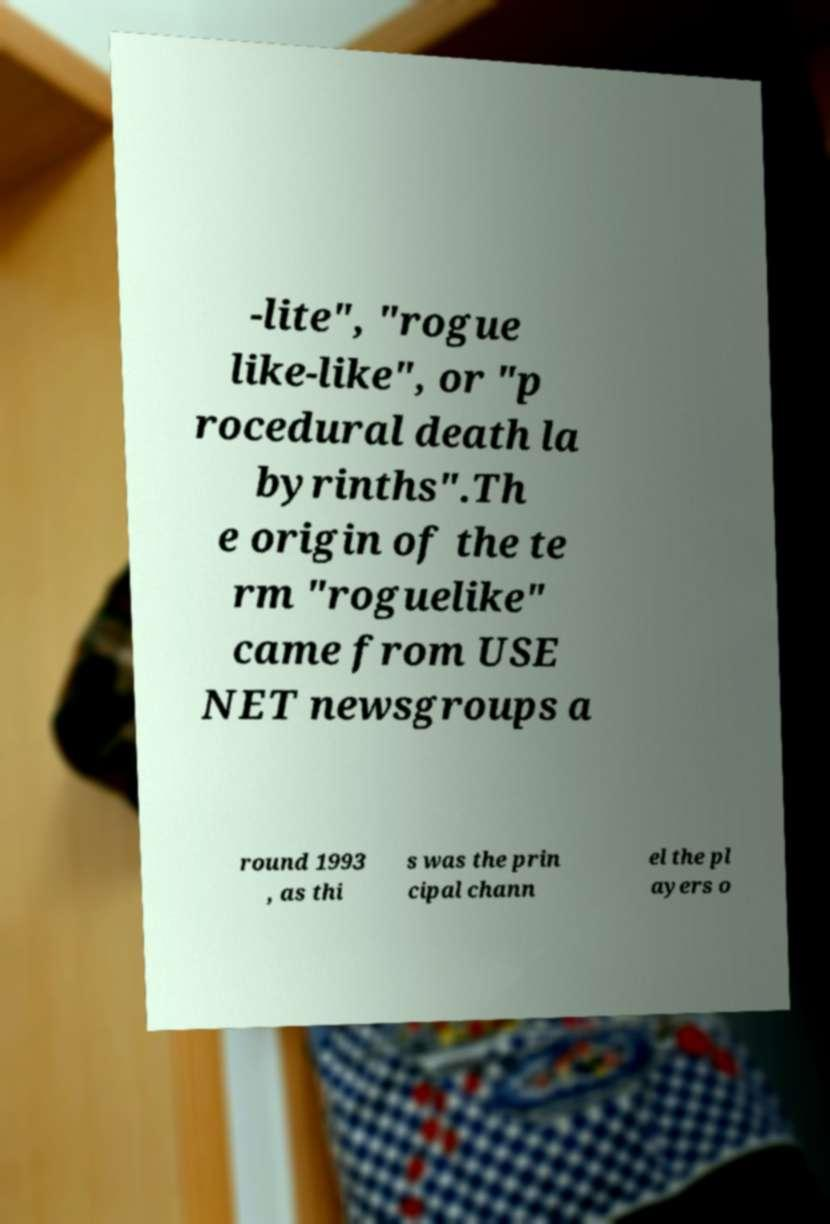Can you accurately transcribe the text from the provided image for me? -lite", "rogue like-like", or "p rocedural death la byrinths".Th e origin of the te rm "roguelike" came from USE NET newsgroups a round 1993 , as thi s was the prin cipal chann el the pl ayers o 